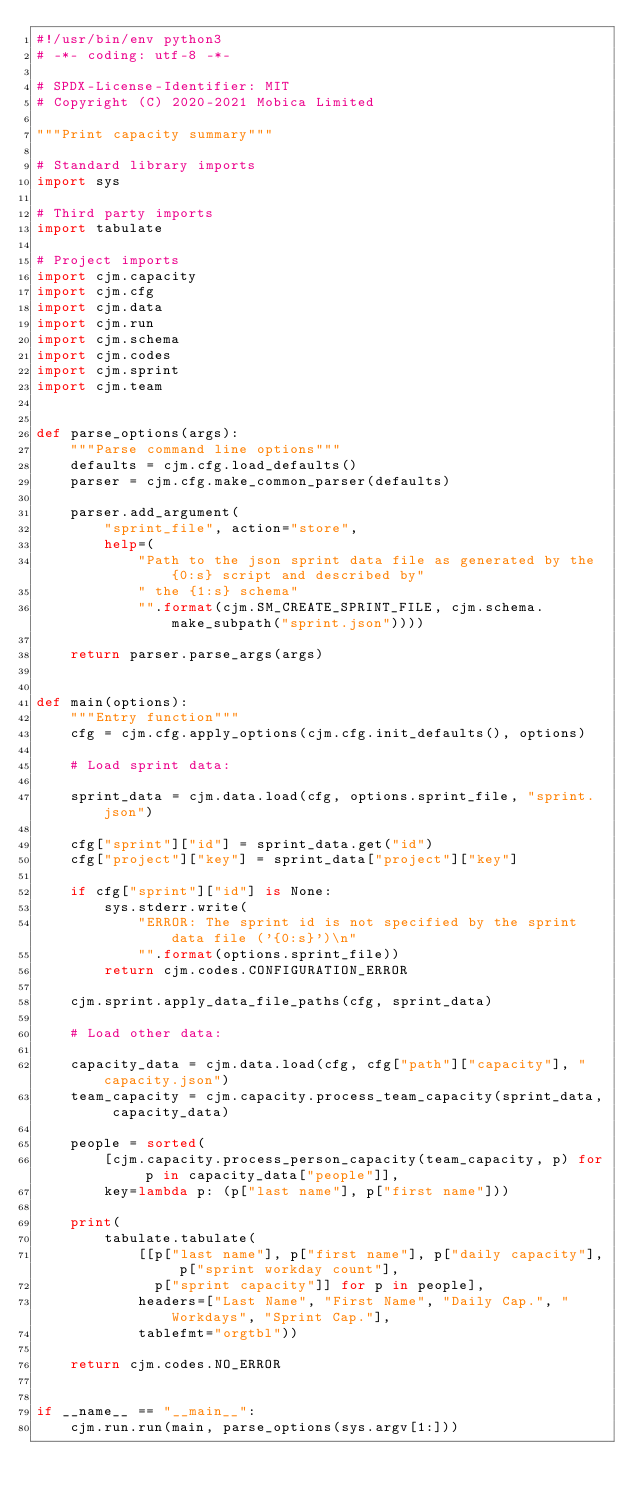Convert code to text. <code><loc_0><loc_0><loc_500><loc_500><_Python_>#!/usr/bin/env python3
# -*- coding: utf-8 -*-

# SPDX-License-Identifier: MIT
# Copyright (C) 2020-2021 Mobica Limited

"""Print capacity summary"""

# Standard library imports
import sys

# Third party imports
import tabulate

# Project imports
import cjm.capacity
import cjm.cfg
import cjm.data
import cjm.run
import cjm.schema
import cjm.codes
import cjm.sprint
import cjm.team


def parse_options(args):
    """Parse command line options"""
    defaults = cjm.cfg.load_defaults()
    parser = cjm.cfg.make_common_parser(defaults)

    parser.add_argument(
        "sprint_file", action="store",
        help=(
            "Path to the json sprint data file as generated by the {0:s} script and described by"
            " the {1:s} schema"
            "".format(cjm.SM_CREATE_SPRINT_FILE, cjm.schema.make_subpath("sprint.json"))))

    return parser.parse_args(args)


def main(options):
    """Entry function"""
    cfg = cjm.cfg.apply_options(cjm.cfg.init_defaults(), options)

    # Load sprint data:

    sprint_data = cjm.data.load(cfg, options.sprint_file, "sprint.json")

    cfg["sprint"]["id"] = sprint_data.get("id")
    cfg["project"]["key"] = sprint_data["project"]["key"]

    if cfg["sprint"]["id"] is None:
        sys.stderr.write(
            "ERROR: The sprint id is not specified by the sprint data file ('{0:s}')\n"
            "".format(options.sprint_file))
        return cjm.codes.CONFIGURATION_ERROR

    cjm.sprint.apply_data_file_paths(cfg, sprint_data)

    # Load other data:

    capacity_data = cjm.data.load(cfg, cfg["path"]["capacity"], "capacity.json")
    team_capacity = cjm.capacity.process_team_capacity(sprint_data, capacity_data)

    people = sorted(
        [cjm.capacity.process_person_capacity(team_capacity, p) for p in capacity_data["people"]],
        key=lambda p: (p["last name"], p["first name"]))

    print(
        tabulate.tabulate(
            [[p["last name"], p["first name"], p["daily capacity"], p["sprint workday count"],
              p["sprint capacity"]] for p in people],
            headers=["Last Name", "First Name", "Daily Cap.", "Workdays", "Sprint Cap."],
            tablefmt="orgtbl"))

    return cjm.codes.NO_ERROR


if __name__ == "__main__":
    cjm.run.run(main, parse_options(sys.argv[1:]))
</code> 